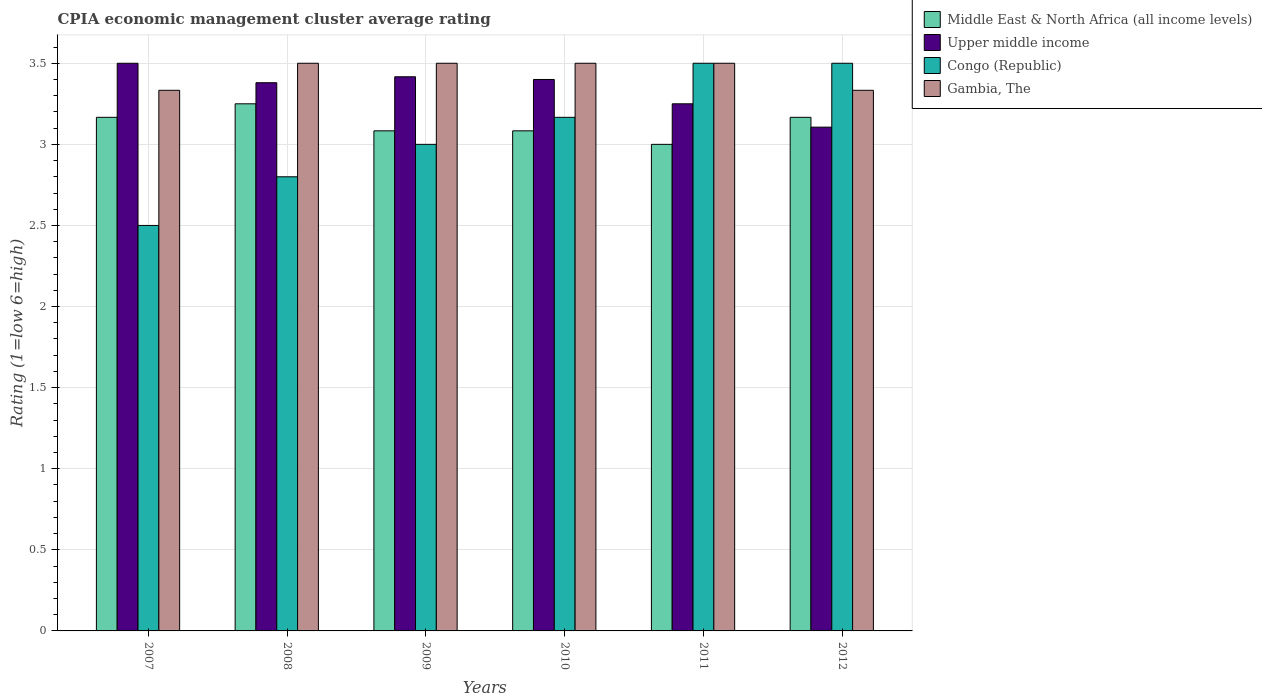Are the number of bars per tick equal to the number of legend labels?
Offer a very short reply. Yes. How many bars are there on the 2nd tick from the right?
Offer a terse response. 4. What is the label of the 5th group of bars from the left?
Offer a terse response. 2011. In how many cases, is the number of bars for a given year not equal to the number of legend labels?
Keep it short and to the point. 0. What is the CPIA rating in Upper middle income in 2011?
Your response must be concise. 3.25. In which year was the CPIA rating in Congo (Republic) maximum?
Offer a very short reply. 2011. In which year was the CPIA rating in Middle East & North Africa (all income levels) minimum?
Provide a succinct answer. 2011. What is the total CPIA rating in Middle East & North Africa (all income levels) in the graph?
Provide a succinct answer. 18.75. What is the difference between the CPIA rating in Middle East & North Africa (all income levels) in 2009 and that in 2012?
Offer a terse response. -0.08. What is the difference between the CPIA rating in Upper middle income in 2008 and the CPIA rating in Middle East & North Africa (all income levels) in 2012?
Your answer should be very brief. 0.21. What is the average CPIA rating in Congo (Republic) per year?
Your answer should be compact. 3.08. In the year 2009, what is the difference between the CPIA rating in Upper middle income and CPIA rating in Gambia, The?
Ensure brevity in your answer.  -0.08. In how many years, is the CPIA rating in Gambia, The greater than 1.8?
Offer a very short reply. 6. What is the ratio of the CPIA rating in Congo (Republic) in 2008 to that in 2011?
Ensure brevity in your answer.  0.8. Is the difference between the CPIA rating in Upper middle income in 2007 and 2011 greater than the difference between the CPIA rating in Gambia, The in 2007 and 2011?
Make the answer very short. Yes. What is the difference between the highest and the second highest CPIA rating in Middle East & North Africa (all income levels)?
Your response must be concise. 0.08. What is the difference between the highest and the lowest CPIA rating in Congo (Republic)?
Your answer should be compact. 1. Is the sum of the CPIA rating in Congo (Republic) in 2010 and 2011 greater than the maximum CPIA rating in Upper middle income across all years?
Your answer should be very brief. Yes. Is it the case that in every year, the sum of the CPIA rating in Middle East & North Africa (all income levels) and CPIA rating in Gambia, The is greater than the sum of CPIA rating in Congo (Republic) and CPIA rating in Upper middle income?
Ensure brevity in your answer.  No. What does the 4th bar from the left in 2007 represents?
Your answer should be very brief. Gambia, The. What does the 1st bar from the right in 2010 represents?
Your answer should be compact. Gambia, The. Is it the case that in every year, the sum of the CPIA rating in Middle East & North Africa (all income levels) and CPIA rating in Congo (Republic) is greater than the CPIA rating in Gambia, The?
Give a very brief answer. Yes. Are all the bars in the graph horizontal?
Make the answer very short. No. How many years are there in the graph?
Make the answer very short. 6. What is the difference between two consecutive major ticks on the Y-axis?
Offer a terse response. 0.5. Are the values on the major ticks of Y-axis written in scientific E-notation?
Your response must be concise. No. Does the graph contain any zero values?
Your answer should be compact. No. How are the legend labels stacked?
Offer a very short reply. Vertical. What is the title of the graph?
Provide a short and direct response. CPIA economic management cluster average rating. What is the label or title of the X-axis?
Give a very brief answer. Years. What is the Rating (1=low 6=high) in Middle East & North Africa (all income levels) in 2007?
Keep it short and to the point. 3.17. What is the Rating (1=low 6=high) of Upper middle income in 2007?
Your response must be concise. 3.5. What is the Rating (1=low 6=high) of Congo (Republic) in 2007?
Your response must be concise. 2.5. What is the Rating (1=low 6=high) of Gambia, The in 2007?
Offer a terse response. 3.33. What is the Rating (1=low 6=high) of Upper middle income in 2008?
Offer a terse response. 3.38. What is the Rating (1=low 6=high) of Gambia, The in 2008?
Your answer should be very brief. 3.5. What is the Rating (1=low 6=high) in Middle East & North Africa (all income levels) in 2009?
Your answer should be very brief. 3.08. What is the Rating (1=low 6=high) in Upper middle income in 2009?
Offer a terse response. 3.42. What is the Rating (1=low 6=high) of Gambia, The in 2009?
Your answer should be compact. 3.5. What is the Rating (1=low 6=high) in Middle East & North Africa (all income levels) in 2010?
Offer a terse response. 3.08. What is the Rating (1=low 6=high) of Upper middle income in 2010?
Ensure brevity in your answer.  3.4. What is the Rating (1=low 6=high) in Congo (Republic) in 2010?
Provide a succinct answer. 3.17. What is the Rating (1=low 6=high) in Gambia, The in 2010?
Make the answer very short. 3.5. What is the Rating (1=low 6=high) in Upper middle income in 2011?
Give a very brief answer. 3.25. What is the Rating (1=low 6=high) of Congo (Republic) in 2011?
Your answer should be compact. 3.5. What is the Rating (1=low 6=high) of Gambia, The in 2011?
Provide a succinct answer. 3.5. What is the Rating (1=low 6=high) of Middle East & North Africa (all income levels) in 2012?
Make the answer very short. 3.17. What is the Rating (1=low 6=high) of Upper middle income in 2012?
Offer a terse response. 3.11. What is the Rating (1=low 6=high) of Gambia, The in 2012?
Keep it short and to the point. 3.33. Across all years, what is the maximum Rating (1=low 6=high) of Congo (Republic)?
Provide a succinct answer. 3.5. Across all years, what is the maximum Rating (1=low 6=high) in Gambia, The?
Ensure brevity in your answer.  3.5. Across all years, what is the minimum Rating (1=low 6=high) in Middle East & North Africa (all income levels)?
Provide a short and direct response. 3. Across all years, what is the minimum Rating (1=low 6=high) of Upper middle income?
Offer a very short reply. 3.11. Across all years, what is the minimum Rating (1=low 6=high) of Gambia, The?
Give a very brief answer. 3.33. What is the total Rating (1=low 6=high) of Middle East & North Africa (all income levels) in the graph?
Your answer should be very brief. 18.75. What is the total Rating (1=low 6=high) of Upper middle income in the graph?
Offer a very short reply. 20.05. What is the total Rating (1=low 6=high) in Congo (Republic) in the graph?
Offer a terse response. 18.47. What is the total Rating (1=low 6=high) of Gambia, The in the graph?
Give a very brief answer. 20.67. What is the difference between the Rating (1=low 6=high) of Middle East & North Africa (all income levels) in 2007 and that in 2008?
Offer a terse response. -0.08. What is the difference between the Rating (1=low 6=high) of Upper middle income in 2007 and that in 2008?
Your answer should be very brief. 0.12. What is the difference between the Rating (1=low 6=high) of Middle East & North Africa (all income levels) in 2007 and that in 2009?
Give a very brief answer. 0.08. What is the difference between the Rating (1=low 6=high) in Upper middle income in 2007 and that in 2009?
Provide a succinct answer. 0.08. What is the difference between the Rating (1=low 6=high) in Congo (Republic) in 2007 and that in 2009?
Your answer should be very brief. -0.5. What is the difference between the Rating (1=low 6=high) in Middle East & North Africa (all income levels) in 2007 and that in 2010?
Offer a terse response. 0.08. What is the difference between the Rating (1=low 6=high) of Upper middle income in 2007 and that in 2010?
Provide a succinct answer. 0.1. What is the difference between the Rating (1=low 6=high) in Middle East & North Africa (all income levels) in 2007 and that in 2011?
Make the answer very short. 0.17. What is the difference between the Rating (1=low 6=high) in Congo (Republic) in 2007 and that in 2011?
Your response must be concise. -1. What is the difference between the Rating (1=low 6=high) in Upper middle income in 2007 and that in 2012?
Keep it short and to the point. 0.39. What is the difference between the Rating (1=low 6=high) in Middle East & North Africa (all income levels) in 2008 and that in 2009?
Your answer should be compact. 0.17. What is the difference between the Rating (1=low 6=high) in Upper middle income in 2008 and that in 2009?
Offer a terse response. -0.04. What is the difference between the Rating (1=low 6=high) in Gambia, The in 2008 and that in 2009?
Ensure brevity in your answer.  0. What is the difference between the Rating (1=low 6=high) in Middle East & North Africa (all income levels) in 2008 and that in 2010?
Offer a terse response. 0.17. What is the difference between the Rating (1=low 6=high) of Upper middle income in 2008 and that in 2010?
Give a very brief answer. -0.02. What is the difference between the Rating (1=low 6=high) of Congo (Republic) in 2008 and that in 2010?
Ensure brevity in your answer.  -0.37. What is the difference between the Rating (1=low 6=high) of Upper middle income in 2008 and that in 2011?
Offer a terse response. 0.13. What is the difference between the Rating (1=low 6=high) in Congo (Republic) in 2008 and that in 2011?
Make the answer very short. -0.7. What is the difference between the Rating (1=low 6=high) of Gambia, The in 2008 and that in 2011?
Keep it short and to the point. 0. What is the difference between the Rating (1=low 6=high) of Middle East & North Africa (all income levels) in 2008 and that in 2012?
Make the answer very short. 0.08. What is the difference between the Rating (1=low 6=high) in Upper middle income in 2008 and that in 2012?
Keep it short and to the point. 0.27. What is the difference between the Rating (1=low 6=high) in Gambia, The in 2008 and that in 2012?
Your answer should be compact. 0.17. What is the difference between the Rating (1=low 6=high) of Middle East & North Africa (all income levels) in 2009 and that in 2010?
Your answer should be very brief. 0. What is the difference between the Rating (1=low 6=high) in Upper middle income in 2009 and that in 2010?
Your answer should be very brief. 0.02. What is the difference between the Rating (1=low 6=high) in Congo (Republic) in 2009 and that in 2010?
Make the answer very short. -0.17. What is the difference between the Rating (1=low 6=high) in Gambia, The in 2009 and that in 2010?
Provide a succinct answer. 0. What is the difference between the Rating (1=low 6=high) of Middle East & North Africa (all income levels) in 2009 and that in 2011?
Offer a terse response. 0.08. What is the difference between the Rating (1=low 6=high) in Congo (Republic) in 2009 and that in 2011?
Ensure brevity in your answer.  -0.5. What is the difference between the Rating (1=low 6=high) of Middle East & North Africa (all income levels) in 2009 and that in 2012?
Make the answer very short. -0.08. What is the difference between the Rating (1=low 6=high) in Upper middle income in 2009 and that in 2012?
Make the answer very short. 0.31. What is the difference between the Rating (1=low 6=high) of Middle East & North Africa (all income levels) in 2010 and that in 2011?
Provide a succinct answer. 0.08. What is the difference between the Rating (1=low 6=high) in Upper middle income in 2010 and that in 2011?
Your answer should be compact. 0.15. What is the difference between the Rating (1=low 6=high) of Gambia, The in 2010 and that in 2011?
Provide a short and direct response. 0. What is the difference between the Rating (1=low 6=high) of Middle East & North Africa (all income levels) in 2010 and that in 2012?
Your answer should be compact. -0.08. What is the difference between the Rating (1=low 6=high) of Upper middle income in 2010 and that in 2012?
Provide a short and direct response. 0.29. What is the difference between the Rating (1=low 6=high) in Gambia, The in 2010 and that in 2012?
Your answer should be compact. 0.17. What is the difference between the Rating (1=low 6=high) of Middle East & North Africa (all income levels) in 2011 and that in 2012?
Your answer should be compact. -0.17. What is the difference between the Rating (1=low 6=high) in Upper middle income in 2011 and that in 2012?
Your answer should be very brief. 0.14. What is the difference between the Rating (1=low 6=high) in Middle East & North Africa (all income levels) in 2007 and the Rating (1=low 6=high) in Upper middle income in 2008?
Your answer should be compact. -0.21. What is the difference between the Rating (1=low 6=high) in Middle East & North Africa (all income levels) in 2007 and the Rating (1=low 6=high) in Congo (Republic) in 2008?
Your answer should be compact. 0.37. What is the difference between the Rating (1=low 6=high) in Upper middle income in 2007 and the Rating (1=low 6=high) in Gambia, The in 2008?
Keep it short and to the point. 0. What is the difference between the Rating (1=low 6=high) in Congo (Republic) in 2007 and the Rating (1=low 6=high) in Gambia, The in 2008?
Make the answer very short. -1. What is the difference between the Rating (1=low 6=high) of Middle East & North Africa (all income levels) in 2007 and the Rating (1=low 6=high) of Congo (Republic) in 2009?
Make the answer very short. 0.17. What is the difference between the Rating (1=low 6=high) in Upper middle income in 2007 and the Rating (1=low 6=high) in Gambia, The in 2009?
Offer a terse response. 0. What is the difference between the Rating (1=low 6=high) of Congo (Republic) in 2007 and the Rating (1=low 6=high) of Gambia, The in 2009?
Provide a succinct answer. -1. What is the difference between the Rating (1=low 6=high) of Middle East & North Africa (all income levels) in 2007 and the Rating (1=low 6=high) of Upper middle income in 2010?
Keep it short and to the point. -0.23. What is the difference between the Rating (1=low 6=high) of Upper middle income in 2007 and the Rating (1=low 6=high) of Congo (Republic) in 2010?
Provide a short and direct response. 0.33. What is the difference between the Rating (1=low 6=high) in Upper middle income in 2007 and the Rating (1=low 6=high) in Gambia, The in 2010?
Offer a very short reply. 0. What is the difference between the Rating (1=low 6=high) of Middle East & North Africa (all income levels) in 2007 and the Rating (1=low 6=high) of Upper middle income in 2011?
Your answer should be compact. -0.08. What is the difference between the Rating (1=low 6=high) of Middle East & North Africa (all income levels) in 2007 and the Rating (1=low 6=high) of Congo (Republic) in 2011?
Your response must be concise. -0.33. What is the difference between the Rating (1=low 6=high) of Middle East & North Africa (all income levels) in 2007 and the Rating (1=low 6=high) of Gambia, The in 2011?
Offer a terse response. -0.33. What is the difference between the Rating (1=low 6=high) in Middle East & North Africa (all income levels) in 2007 and the Rating (1=low 6=high) in Upper middle income in 2012?
Offer a terse response. 0.06. What is the difference between the Rating (1=low 6=high) of Middle East & North Africa (all income levels) in 2007 and the Rating (1=low 6=high) of Congo (Republic) in 2012?
Offer a very short reply. -0.33. What is the difference between the Rating (1=low 6=high) of Upper middle income in 2007 and the Rating (1=low 6=high) of Congo (Republic) in 2012?
Offer a very short reply. 0. What is the difference between the Rating (1=low 6=high) of Middle East & North Africa (all income levels) in 2008 and the Rating (1=low 6=high) of Upper middle income in 2009?
Ensure brevity in your answer.  -0.17. What is the difference between the Rating (1=low 6=high) in Middle East & North Africa (all income levels) in 2008 and the Rating (1=low 6=high) in Congo (Republic) in 2009?
Give a very brief answer. 0.25. What is the difference between the Rating (1=low 6=high) of Upper middle income in 2008 and the Rating (1=low 6=high) of Congo (Republic) in 2009?
Your answer should be compact. 0.38. What is the difference between the Rating (1=low 6=high) in Upper middle income in 2008 and the Rating (1=low 6=high) in Gambia, The in 2009?
Offer a terse response. -0.12. What is the difference between the Rating (1=low 6=high) in Middle East & North Africa (all income levels) in 2008 and the Rating (1=low 6=high) in Upper middle income in 2010?
Offer a very short reply. -0.15. What is the difference between the Rating (1=low 6=high) in Middle East & North Africa (all income levels) in 2008 and the Rating (1=low 6=high) in Congo (Republic) in 2010?
Provide a short and direct response. 0.08. What is the difference between the Rating (1=low 6=high) of Middle East & North Africa (all income levels) in 2008 and the Rating (1=low 6=high) of Gambia, The in 2010?
Your answer should be compact. -0.25. What is the difference between the Rating (1=low 6=high) of Upper middle income in 2008 and the Rating (1=low 6=high) of Congo (Republic) in 2010?
Your response must be concise. 0.21. What is the difference between the Rating (1=low 6=high) in Upper middle income in 2008 and the Rating (1=low 6=high) in Gambia, The in 2010?
Offer a very short reply. -0.12. What is the difference between the Rating (1=low 6=high) of Middle East & North Africa (all income levels) in 2008 and the Rating (1=low 6=high) of Upper middle income in 2011?
Offer a terse response. 0. What is the difference between the Rating (1=low 6=high) of Middle East & North Africa (all income levels) in 2008 and the Rating (1=low 6=high) of Gambia, The in 2011?
Your answer should be compact. -0.25. What is the difference between the Rating (1=low 6=high) of Upper middle income in 2008 and the Rating (1=low 6=high) of Congo (Republic) in 2011?
Offer a terse response. -0.12. What is the difference between the Rating (1=low 6=high) in Upper middle income in 2008 and the Rating (1=low 6=high) in Gambia, The in 2011?
Ensure brevity in your answer.  -0.12. What is the difference between the Rating (1=low 6=high) in Congo (Republic) in 2008 and the Rating (1=low 6=high) in Gambia, The in 2011?
Provide a succinct answer. -0.7. What is the difference between the Rating (1=low 6=high) of Middle East & North Africa (all income levels) in 2008 and the Rating (1=low 6=high) of Upper middle income in 2012?
Make the answer very short. 0.14. What is the difference between the Rating (1=low 6=high) of Middle East & North Africa (all income levels) in 2008 and the Rating (1=low 6=high) of Congo (Republic) in 2012?
Offer a terse response. -0.25. What is the difference between the Rating (1=low 6=high) of Middle East & North Africa (all income levels) in 2008 and the Rating (1=low 6=high) of Gambia, The in 2012?
Offer a very short reply. -0.08. What is the difference between the Rating (1=low 6=high) of Upper middle income in 2008 and the Rating (1=low 6=high) of Congo (Republic) in 2012?
Give a very brief answer. -0.12. What is the difference between the Rating (1=low 6=high) in Upper middle income in 2008 and the Rating (1=low 6=high) in Gambia, The in 2012?
Your answer should be compact. 0.05. What is the difference between the Rating (1=low 6=high) of Congo (Republic) in 2008 and the Rating (1=low 6=high) of Gambia, The in 2012?
Your answer should be very brief. -0.53. What is the difference between the Rating (1=low 6=high) in Middle East & North Africa (all income levels) in 2009 and the Rating (1=low 6=high) in Upper middle income in 2010?
Keep it short and to the point. -0.32. What is the difference between the Rating (1=low 6=high) of Middle East & North Africa (all income levels) in 2009 and the Rating (1=low 6=high) of Congo (Republic) in 2010?
Your response must be concise. -0.08. What is the difference between the Rating (1=low 6=high) in Middle East & North Africa (all income levels) in 2009 and the Rating (1=low 6=high) in Gambia, The in 2010?
Give a very brief answer. -0.42. What is the difference between the Rating (1=low 6=high) in Upper middle income in 2009 and the Rating (1=low 6=high) in Gambia, The in 2010?
Make the answer very short. -0.08. What is the difference between the Rating (1=low 6=high) in Congo (Republic) in 2009 and the Rating (1=low 6=high) in Gambia, The in 2010?
Ensure brevity in your answer.  -0.5. What is the difference between the Rating (1=low 6=high) in Middle East & North Africa (all income levels) in 2009 and the Rating (1=low 6=high) in Congo (Republic) in 2011?
Offer a very short reply. -0.42. What is the difference between the Rating (1=low 6=high) in Middle East & North Africa (all income levels) in 2009 and the Rating (1=low 6=high) in Gambia, The in 2011?
Give a very brief answer. -0.42. What is the difference between the Rating (1=low 6=high) in Upper middle income in 2009 and the Rating (1=low 6=high) in Congo (Republic) in 2011?
Your answer should be very brief. -0.08. What is the difference between the Rating (1=low 6=high) in Upper middle income in 2009 and the Rating (1=low 6=high) in Gambia, The in 2011?
Your answer should be very brief. -0.08. What is the difference between the Rating (1=low 6=high) of Congo (Republic) in 2009 and the Rating (1=low 6=high) of Gambia, The in 2011?
Provide a short and direct response. -0.5. What is the difference between the Rating (1=low 6=high) in Middle East & North Africa (all income levels) in 2009 and the Rating (1=low 6=high) in Upper middle income in 2012?
Keep it short and to the point. -0.02. What is the difference between the Rating (1=low 6=high) in Middle East & North Africa (all income levels) in 2009 and the Rating (1=low 6=high) in Congo (Republic) in 2012?
Keep it short and to the point. -0.42. What is the difference between the Rating (1=low 6=high) of Upper middle income in 2009 and the Rating (1=low 6=high) of Congo (Republic) in 2012?
Your answer should be compact. -0.08. What is the difference between the Rating (1=low 6=high) in Upper middle income in 2009 and the Rating (1=low 6=high) in Gambia, The in 2012?
Your response must be concise. 0.08. What is the difference between the Rating (1=low 6=high) of Middle East & North Africa (all income levels) in 2010 and the Rating (1=low 6=high) of Congo (Republic) in 2011?
Offer a very short reply. -0.42. What is the difference between the Rating (1=low 6=high) in Middle East & North Africa (all income levels) in 2010 and the Rating (1=low 6=high) in Gambia, The in 2011?
Offer a terse response. -0.42. What is the difference between the Rating (1=low 6=high) of Upper middle income in 2010 and the Rating (1=low 6=high) of Congo (Republic) in 2011?
Your response must be concise. -0.1. What is the difference between the Rating (1=low 6=high) in Middle East & North Africa (all income levels) in 2010 and the Rating (1=low 6=high) in Upper middle income in 2012?
Give a very brief answer. -0.02. What is the difference between the Rating (1=low 6=high) in Middle East & North Africa (all income levels) in 2010 and the Rating (1=low 6=high) in Congo (Republic) in 2012?
Ensure brevity in your answer.  -0.42. What is the difference between the Rating (1=low 6=high) of Upper middle income in 2010 and the Rating (1=low 6=high) of Gambia, The in 2012?
Offer a very short reply. 0.07. What is the difference between the Rating (1=low 6=high) in Middle East & North Africa (all income levels) in 2011 and the Rating (1=low 6=high) in Upper middle income in 2012?
Offer a very short reply. -0.11. What is the difference between the Rating (1=low 6=high) of Middle East & North Africa (all income levels) in 2011 and the Rating (1=low 6=high) of Congo (Republic) in 2012?
Ensure brevity in your answer.  -0.5. What is the difference between the Rating (1=low 6=high) of Upper middle income in 2011 and the Rating (1=low 6=high) of Congo (Republic) in 2012?
Give a very brief answer. -0.25. What is the difference between the Rating (1=low 6=high) in Upper middle income in 2011 and the Rating (1=low 6=high) in Gambia, The in 2012?
Make the answer very short. -0.08. What is the difference between the Rating (1=low 6=high) in Congo (Republic) in 2011 and the Rating (1=low 6=high) in Gambia, The in 2012?
Make the answer very short. 0.17. What is the average Rating (1=low 6=high) in Middle East & North Africa (all income levels) per year?
Keep it short and to the point. 3.12. What is the average Rating (1=low 6=high) in Upper middle income per year?
Provide a succinct answer. 3.34. What is the average Rating (1=low 6=high) of Congo (Republic) per year?
Offer a very short reply. 3.08. What is the average Rating (1=low 6=high) of Gambia, The per year?
Keep it short and to the point. 3.44. In the year 2007, what is the difference between the Rating (1=low 6=high) in Middle East & North Africa (all income levels) and Rating (1=low 6=high) in Upper middle income?
Give a very brief answer. -0.33. In the year 2007, what is the difference between the Rating (1=low 6=high) in Middle East & North Africa (all income levels) and Rating (1=low 6=high) in Congo (Republic)?
Your response must be concise. 0.67. In the year 2007, what is the difference between the Rating (1=low 6=high) in Upper middle income and Rating (1=low 6=high) in Gambia, The?
Your answer should be compact. 0.17. In the year 2007, what is the difference between the Rating (1=low 6=high) in Congo (Republic) and Rating (1=low 6=high) in Gambia, The?
Offer a very short reply. -0.83. In the year 2008, what is the difference between the Rating (1=low 6=high) of Middle East & North Africa (all income levels) and Rating (1=low 6=high) of Upper middle income?
Offer a very short reply. -0.13. In the year 2008, what is the difference between the Rating (1=low 6=high) of Middle East & North Africa (all income levels) and Rating (1=low 6=high) of Congo (Republic)?
Your answer should be compact. 0.45. In the year 2008, what is the difference between the Rating (1=low 6=high) in Upper middle income and Rating (1=low 6=high) in Congo (Republic)?
Provide a succinct answer. 0.58. In the year 2008, what is the difference between the Rating (1=low 6=high) of Upper middle income and Rating (1=low 6=high) of Gambia, The?
Your answer should be compact. -0.12. In the year 2009, what is the difference between the Rating (1=low 6=high) of Middle East & North Africa (all income levels) and Rating (1=low 6=high) of Upper middle income?
Your answer should be very brief. -0.33. In the year 2009, what is the difference between the Rating (1=low 6=high) in Middle East & North Africa (all income levels) and Rating (1=low 6=high) in Congo (Republic)?
Offer a very short reply. 0.08. In the year 2009, what is the difference between the Rating (1=low 6=high) in Middle East & North Africa (all income levels) and Rating (1=low 6=high) in Gambia, The?
Your answer should be compact. -0.42. In the year 2009, what is the difference between the Rating (1=low 6=high) of Upper middle income and Rating (1=low 6=high) of Congo (Republic)?
Ensure brevity in your answer.  0.42. In the year 2009, what is the difference between the Rating (1=low 6=high) of Upper middle income and Rating (1=low 6=high) of Gambia, The?
Offer a very short reply. -0.08. In the year 2010, what is the difference between the Rating (1=low 6=high) in Middle East & North Africa (all income levels) and Rating (1=low 6=high) in Upper middle income?
Keep it short and to the point. -0.32. In the year 2010, what is the difference between the Rating (1=low 6=high) of Middle East & North Africa (all income levels) and Rating (1=low 6=high) of Congo (Republic)?
Your response must be concise. -0.08. In the year 2010, what is the difference between the Rating (1=low 6=high) in Middle East & North Africa (all income levels) and Rating (1=low 6=high) in Gambia, The?
Keep it short and to the point. -0.42. In the year 2010, what is the difference between the Rating (1=low 6=high) of Upper middle income and Rating (1=low 6=high) of Congo (Republic)?
Your response must be concise. 0.23. In the year 2010, what is the difference between the Rating (1=low 6=high) of Upper middle income and Rating (1=low 6=high) of Gambia, The?
Your response must be concise. -0.1. In the year 2010, what is the difference between the Rating (1=low 6=high) in Congo (Republic) and Rating (1=low 6=high) in Gambia, The?
Ensure brevity in your answer.  -0.33. In the year 2011, what is the difference between the Rating (1=low 6=high) of Middle East & North Africa (all income levels) and Rating (1=low 6=high) of Congo (Republic)?
Make the answer very short. -0.5. In the year 2011, what is the difference between the Rating (1=low 6=high) of Upper middle income and Rating (1=low 6=high) of Congo (Republic)?
Provide a short and direct response. -0.25. In the year 2011, what is the difference between the Rating (1=low 6=high) in Upper middle income and Rating (1=low 6=high) in Gambia, The?
Ensure brevity in your answer.  -0.25. In the year 2012, what is the difference between the Rating (1=low 6=high) of Middle East & North Africa (all income levels) and Rating (1=low 6=high) of Upper middle income?
Give a very brief answer. 0.06. In the year 2012, what is the difference between the Rating (1=low 6=high) in Upper middle income and Rating (1=low 6=high) in Congo (Republic)?
Give a very brief answer. -0.39. In the year 2012, what is the difference between the Rating (1=low 6=high) in Upper middle income and Rating (1=low 6=high) in Gambia, The?
Provide a short and direct response. -0.23. What is the ratio of the Rating (1=low 6=high) in Middle East & North Africa (all income levels) in 2007 to that in 2008?
Your response must be concise. 0.97. What is the ratio of the Rating (1=low 6=high) in Upper middle income in 2007 to that in 2008?
Provide a succinct answer. 1.04. What is the ratio of the Rating (1=low 6=high) in Congo (Republic) in 2007 to that in 2008?
Your response must be concise. 0.89. What is the ratio of the Rating (1=low 6=high) of Gambia, The in 2007 to that in 2008?
Provide a short and direct response. 0.95. What is the ratio of the Rating (1=low 6=high) of Middle East & North Africa (all income levels) in 2007 to that in 2009?
Offer a very short reply. 1.03. What is the ratio of the Rating (1=low 6=high) in Upper middle income in 2007 to that in 2009?
Your answer should be very brief. 1.02. What is the ratio of the Rating (1=low 6=high) in Congo (Republic) in 2007 to that in 2009?
Provide a succinct answer. 0.83. What is the ratio of the Rating (1=low 6=high) in Gambia, The in 2007 to that in 2009?
Give a very brief answer. 0.95. What is the ratio of the Rating (1=low 6=high) in Middle East & North Africa (all income levels) in 2007 to that in 2010?
Your answer should be very brief. 1.03. What is the ratio of the Rating (1=low 6=high) in Upper middle income in 2007 to that in 2010?
Ensure brevity in your answer.  1.03. What is the ratio of the Rating (1=low 6=high) of Congo (Republic) in 2007 to that in 2010?
Make the answer very short. 0.79. What is the ratio of the Rating (1=low 6=high) of Gambia, The in 2007 to that in 2010?
Offer a very short reply. 0.95. What is the ratio of the Rating (1=low 6=high) of Middle East & North Africa (all income levels) in 2007 to that in 2011?
Your response must be concise. 1.06. What is the ratio of the Rating (1=low 6=high) of Gambia, The in 2007 to that in 2011?
Give a very brief answer. 0.95. What is the ratio of the Rating (1=low 6=high) in Upper middle income in 2007 to that in 2012?
Make the answer very short. 1.13. What is the ratio of the Rating (1=low 6=high) of Gambia, The in 2007 to that in 2012?
Keep it short and to the point. 1. What is the ratio of the Rating (1=low 6=high) of Middle East & North Africa (all income levels) in 2008 to that in 2009?
Provide a short and direct response. 1.05. What is the ratio of the Rating (1=low 6=high) of Upper middle income in 2008 to that in 2009?
Provide a succinct answer. 0.99. What is the ratio of the Rating (1=low 6=high) of Congo (Republic) in 2008 to that in 2009?
Keep it short and to the point. 0.93. What is the ratio of the Rating (1=low 6=high) of Gambia, The in 2008 to that in 2009?
Your answer should be very brief. 1. What is the ratio of the Rating (1=low 6=high) in Middle East & North Africa (all income levels) in 2008 to that in 2010?
Your answer should be very brief. 1.05. What is the ratio of the Rating (1=low 6=high) of Upper middle income in 2008 to that in 2010?
Provide a short and direct response. 0.99. What is the ratio of the Rating (1=low 6=high) of Congo (Republic) in 2008 to that in 2010?
Offer a very short reply. 0.88. What is the ratio of the Rating (1=low 6=high) in Middle East & North Africa (all income levels) in 2008 to that in 2011?
Provide a succinct answer. 1.08. What is the ratio of the Rating (1=low 6=high) in Upper middle income in 2008 to that in 2011?
Your answer should be very brief. 1.04. What is the ratio of the Rating (1=low 6=high) in Middle East & North Africa (all income levels) in 2008 to that in 2012?
Offer a terse response. 1.03. What is the ratio of the Rating (1=low 6=high) of Upper middle income in 2008 to that in 2012?
Ensure brevity in your answer.  1.09. What is the ratio of the Rating (1=low 6=high) of Congo (Republic) in 2008 to that in 2012?
Your answer should be compact. 0.8. What is the ratio of the Rating (1=low 6=high) in Upper middle income in 2009 to that in 2010?
Your response must be concise. 1. What is the ratio of the Rating (1=low 6=high) of Gambia, The in 2009 to that in 2010?
Your answer should be very brief. 1. What is the ratio of the Rating (1=low 6=high) of Middle East & North Africa (all income levels) in 2009 to that in 2011?
Your response must be concise. 1.03. What is the ratio of the Rating (1=low 6=high) in Upper middle income in 2009 to that in 2011?
Your answer should be compact. 1.05. What is the ratio of the Rating (1=low 6=high) in Gambia, The in 2009 to that in 2011?
Your answer should be compact. 1. What is the ratio of the Rating (1=low 6=high) of Middle East & North Africa (all income levels) in 2009 to that in 2012?
Offer a very short reply. 0.97. What is the ratio of the Rating (1=low 6=high) of Upper middle income in 2009 to that in 2012?
Provide a succinct answer. 1.1. What is the ratio of the Rating (1=low 6=high) in Gambia, The in 2009 to that in 2012?
Offer a terse response. 1.05. What is the ratio of the Rating (1=low 6=high) of Middle East & North Africa (all income levels) in 2010 to that in 2011?
Keep it short and to the point. 1.03. What is the ratio of the Rating (1=low 6=high) of Upper middle income in 2010 to that in 2011?
Your answer should be compact. 1.05. What is the ratio of the Rating (1=low 6=high) in Congo (Republic) in 2010 to that in 2011?
Your response must be concise. 0.9. What is the ratio of the Rating (1=low 6=high) in Middle East & North Africa (all income levels) in 2010 to that in 2012?
Your response must be concise. 0.97. What is the ratio of the Rating (1=low 6=high) of Upper middle income in 2010 to that in 2012?
Make the answer very short. 1.09. What is the ratio of the Rating (1=low 6=high) of Congo (Republic) in 2010 to that in 2012?
Give a very brief answer. 0.9. What is the ratio of the Rating (1=low 6=high) of Middle East & North Africa (all income levels) in 2011 to that in 2012?
Your answer should be compact. 0.95. What is the ratio of the Rating (1=low 6=high) of Upper middle income in 2011 to that in 2012?
Provide a short and direct response. 1.05. What is the difference between the highest and the second highest Rating (1=low 6=high) of Middle East & North Africa (all income levels)?
Your answer should be very brief. 0.08. What is the difference between the highest and the second highest Rating (1=low 6=high) in Upper middle income?
Give a very brief answer. 0.08. What is the difference between the highest and the second highest Rating (1=low 6=high) in Gambia, The?
Keep it short and to the point. 0. What is the difference between the highest and the lowest Rating (1=low 6=high) in Middle East & North Africa (all income levels)?
Offer a terse response. 0.25. What is the difference between the highest and the lowest Rating (1=low 6=high) of Upper middle income?
Keep it short and to the point. 0.39. What is the difference between the highest and the lowest Rating (1=low 6=high) in Gambia, The?
Make the answer very short. 0.17. 